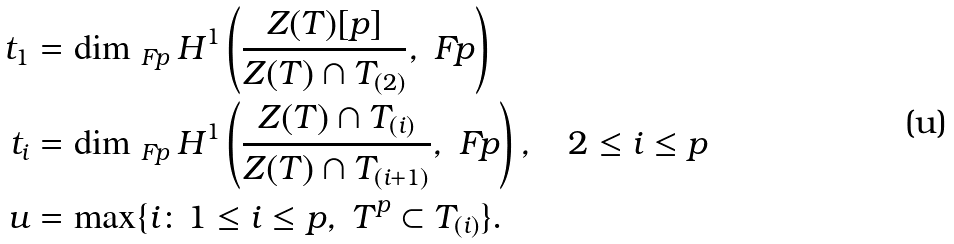<formula> <loc_0><loc_0><loc_500><loc_500>t _ { 1 } & = \dim _ { \ F p } H ^ { 1 } \left ( \frac { Z ( T ) [ p ] } { Z ( T ) \cap T _ { ( 2 ) } } , \ F p \right ) \\ t _ { i } & = \dim _ { \ F p } H ^ { 1 } \left ( \frac { { Z ( T ) \cap T _ { ( i ) } } } { Z ( T ) \cap T _ { ( i + 1 ) } } , \ F p \right ) , \quad 2 \leq i \leq p \\ u & = \max \{ i \colon 1 \leq i \leq p , \ T ^ { p } \subset T _ { ( i ) } \} .</formula> 